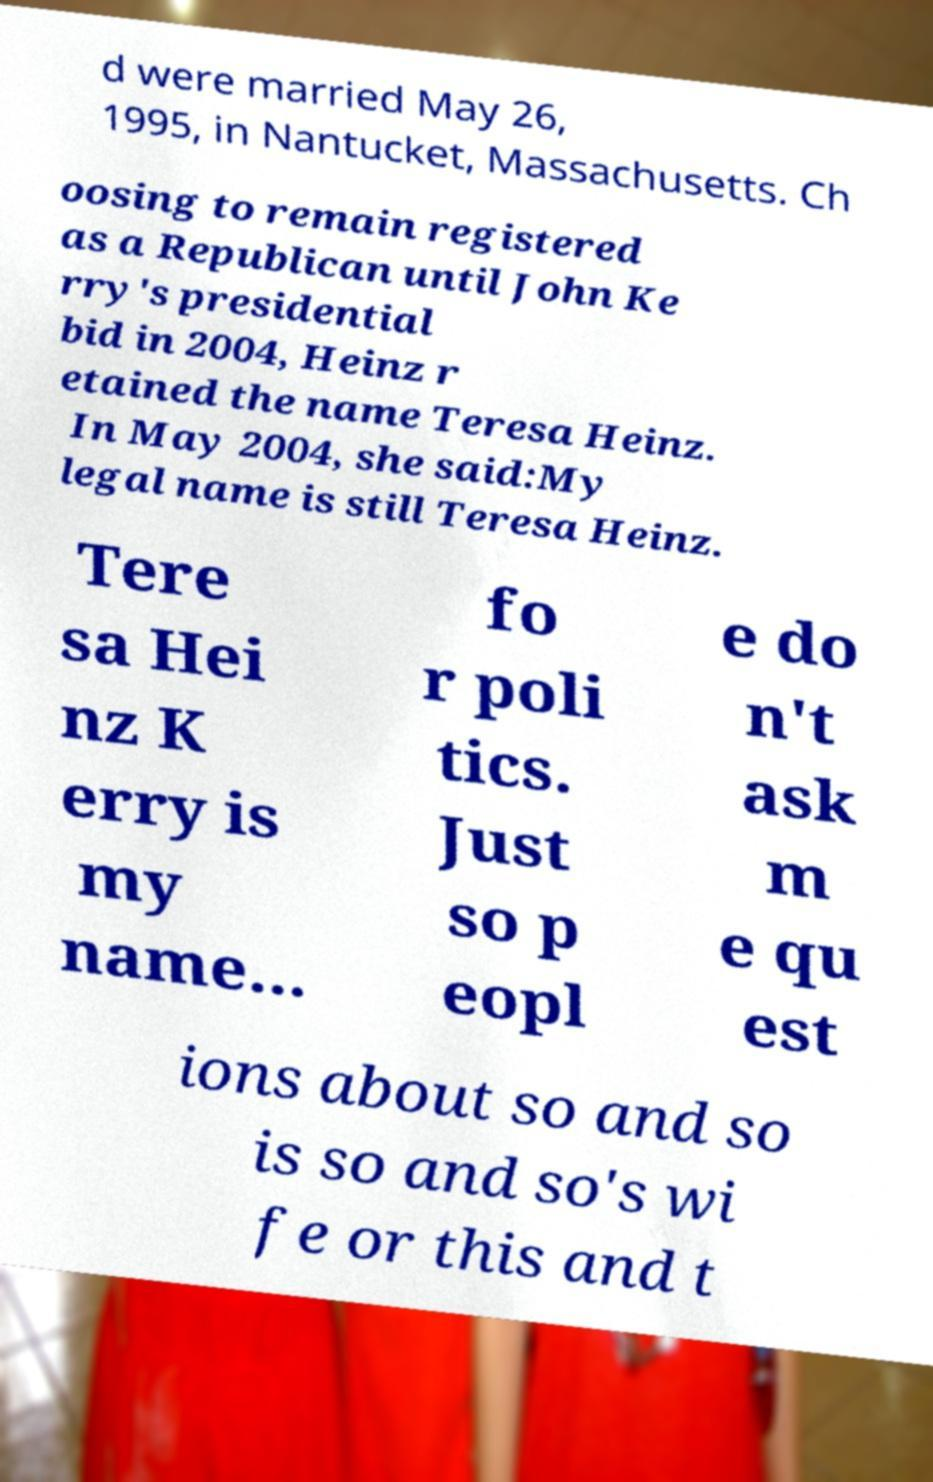Please read and relay the text visible in this image. What does it say? d were married May 26, 1995, in Nantucket, Massachusetts. Ch oosing to remain registered as a Republican until John Ke rry's presidential bid in 2004, Heinz r etained the name Teresa Heinz. In May 2004, she said:My legal name is still Teresa Heinz. Tere sa Hei nz K erry is my name... fo r poli tics. Just so p eopl e do n't ask m e qu est ions about so and so is so and so's wi fe or this and t 